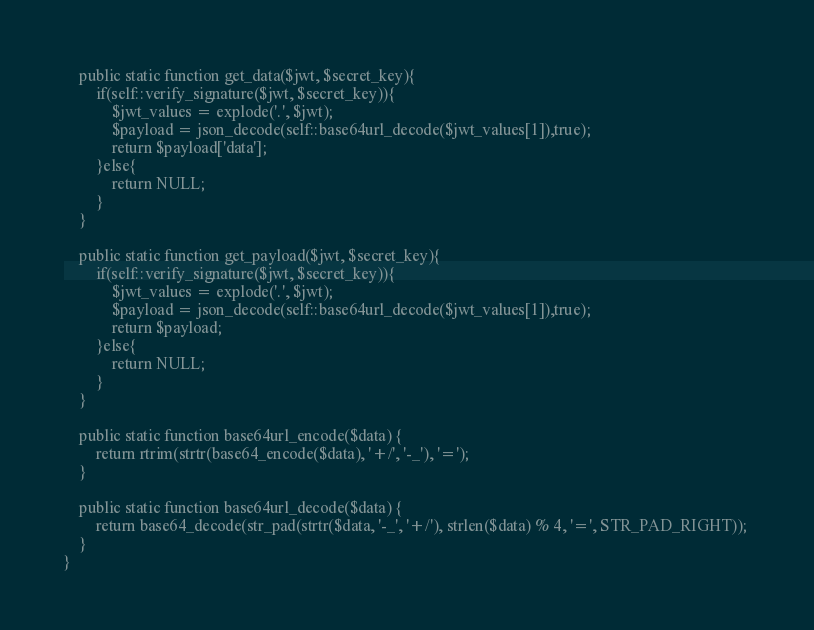<code> <loc_0><loc_0><loc_500><loc_500><_PHP_>    public static function get_data($jwt, $secret_key){
        if(self::verify_signature($jwt, $secret_key)){
            $jwt_values = explode('.', $jwt);
            $payload = json_decode(self::base64url_decode($jwt_values[1]),true);
            return $payload['data'];
        }else{
            return NULL;
        }
    }

    public static function get_payload($jwt, $secret_key){
        if(self::verify_signature($jwt, $secret_key)){
            $jwt_values = explode('.', $jwt);
            $payload = json_decode(self::base64url_decode($jwt_values[1]),true);
            return $payload;
        }else{
            return NULL;
        }
    }

    public static function base64url_encode($data) { 
        return rtrim(strtr(base64_encode($data), '+/', '-_'), '='); 
    } 
      
    public static function base64url_decode($data) { 
        return base64_decode(str_pad(strtr($data, '-_', '+/'), strlen($data) % 4, '=', STR_PAD_RIGHT)); 
    } 
}</code> 